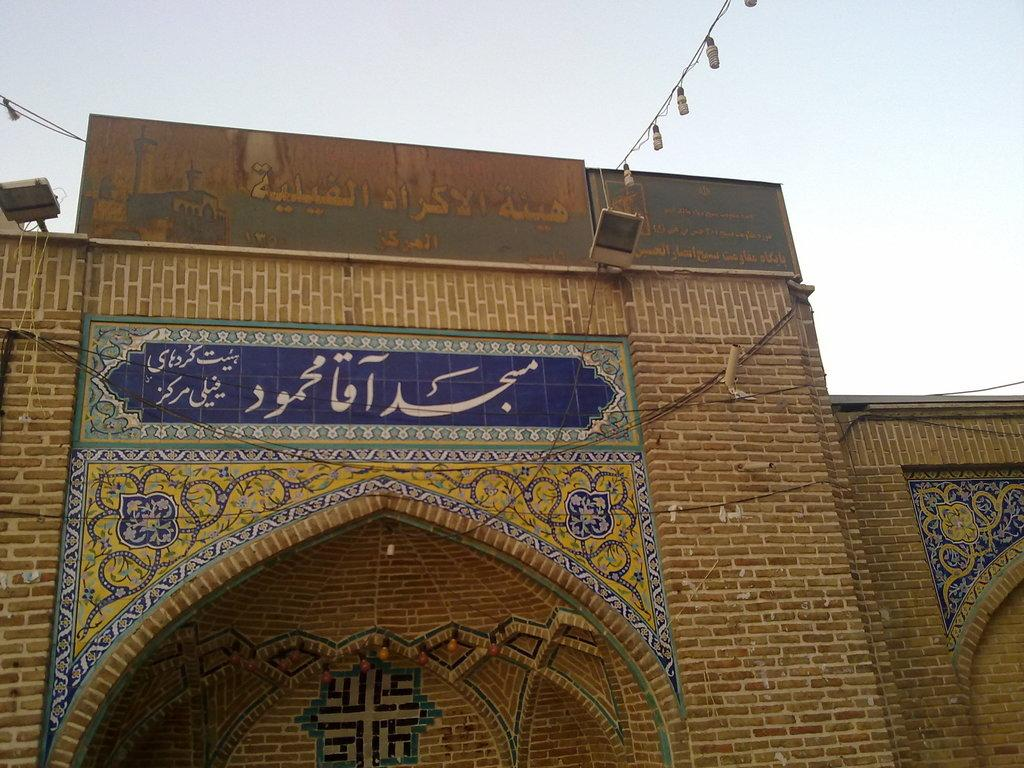What is the main subject in the center of the image? There is a building in the center of the image. What can be seen on the building? There is text written on the wall of the building. What type of lighting is present in the image? There are lights hanging in the image. How would you describe the weather in the image? The sky is cloudy in the image. Where is the playground located in the image? There is no playground present in the image. What type of balls can be seen being used by the judge in the image? There is no judge or balls present in the image. 